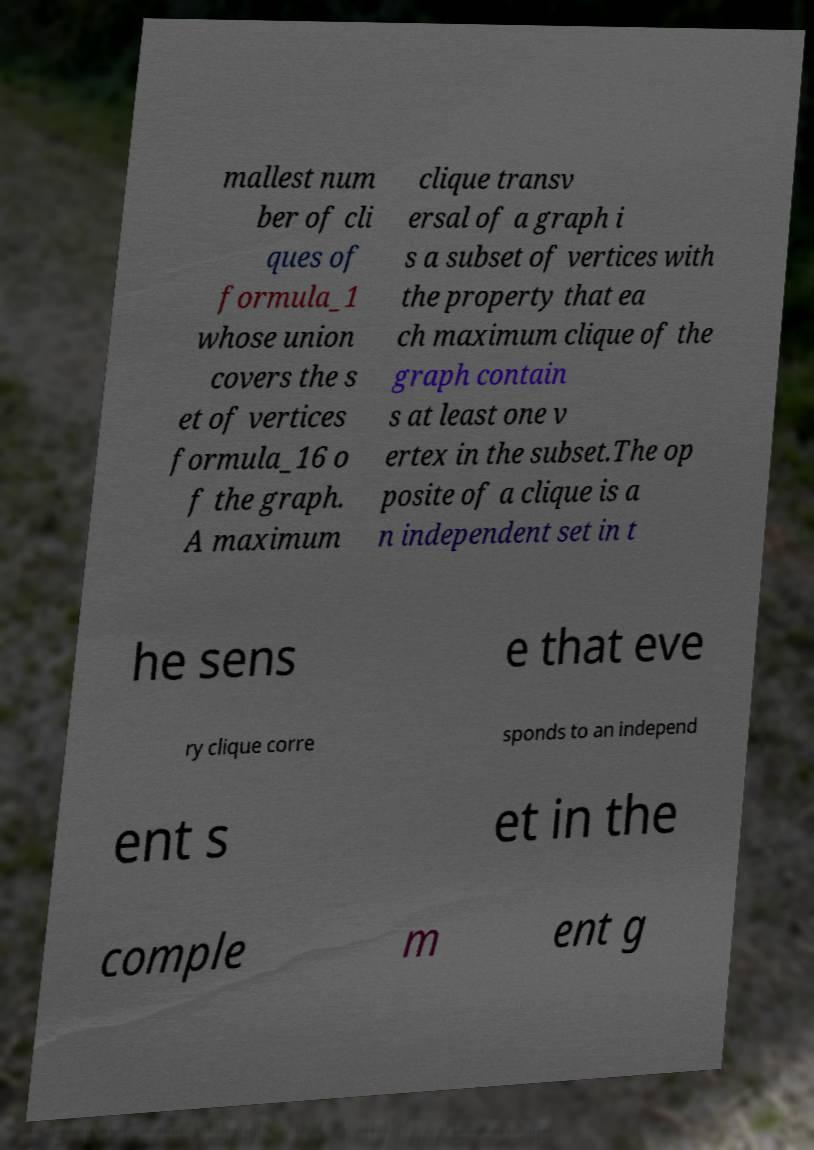Can you read and provide the text displayed in the image?This photo seems to have some interesting text. Can you extract and type it out for me? mallest num ber of cli ques of formula_1 whose union covers the s et of vertices formula_16 o f the graph. A maximum clique transv ersal of a graph i s a subset of vertices with the property that ea ch maximum clique of the graph contain s at least one v ertex in the subset.The op posite of a clique is a n independent set in t he sens e that eve ry clique corre sponds to an independ ent s et in the comple m ent g 